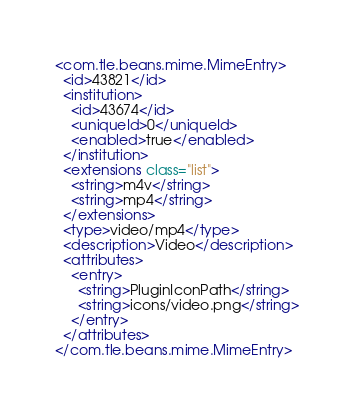<code> <loc_0><loc_0><loc_500><loc_500><_XML_><com.tle.beans.mime.MimeEntry>
  <id>43821</id>
  <institution>
    <id>43674</id>
    <uniqueId>0</uniqueId>
    <enabled>true</enabled>
  </institution>
  <extensions class="list">
    <string>m4v</string>
    <string>mp4</string>
  </extensions>
  <type>video/mp4</type>
  <description>Video</description>
  <attributes>
    <entry>
      <string>PluginIconPath</string>
      <string>icons/video.png</string>
    </entry>
  </attributes>
</com.tle.beans.mime.MimeEntry></code> 